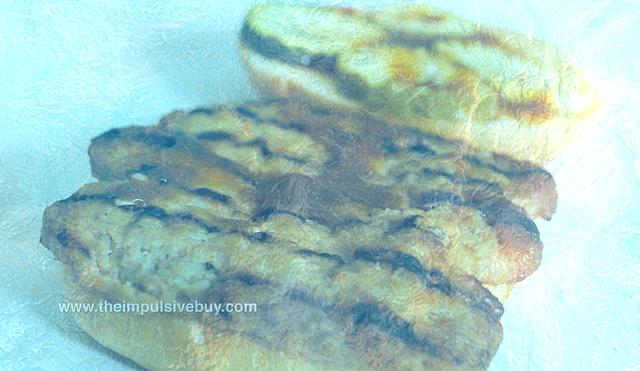Considering the bread's appearance, can you guess the type of bread it is? Judging by the shape and the distinct grill marks, the bread strongly resembles a panini or ciabatta loaf, commonly used for Italian sandwiches or as an accompaniment to salads and soups. Its thick crust and visible grill marks suggest it could have been pressed and toasted, enhancing its flavor profile. 